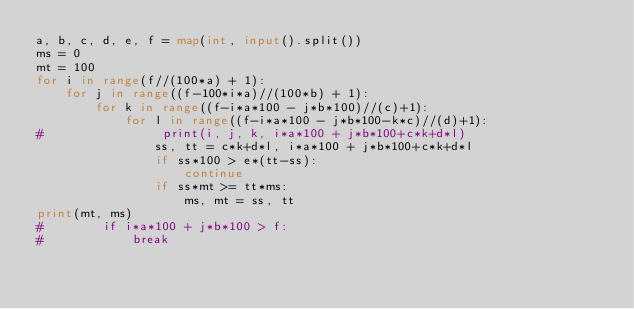<code> <loc_0><loc_0><loc_500><loc_500><_Python_>a, b, c, d, e, f = map(int, input().split())
ms = 0
mt = 100
for i in range(f//(100*a) + 1):
    for j in range((f-100*i*a)//(100*b) + 1):
        for k in range((f-i*a*100 - j*b*100)//(c)+1):
            for l in range((f-i*a*100 - j*b*100-k*c)//(d)+1):
#                print(i, j, k, i*a*100 + j*b*100+c*k+d*l)
                ss, tt = c*k+d*l, i*a*100 + j*b*100+c*k+d*l
                if ss*100 > e*(tt-ss):
                    continue
                if ss*mt >= tt*ms:
                    ms, mt = ss, tt
print(mt, ms)
#        if i*a*100 + j*b*100 > f:
#            break
</code> 